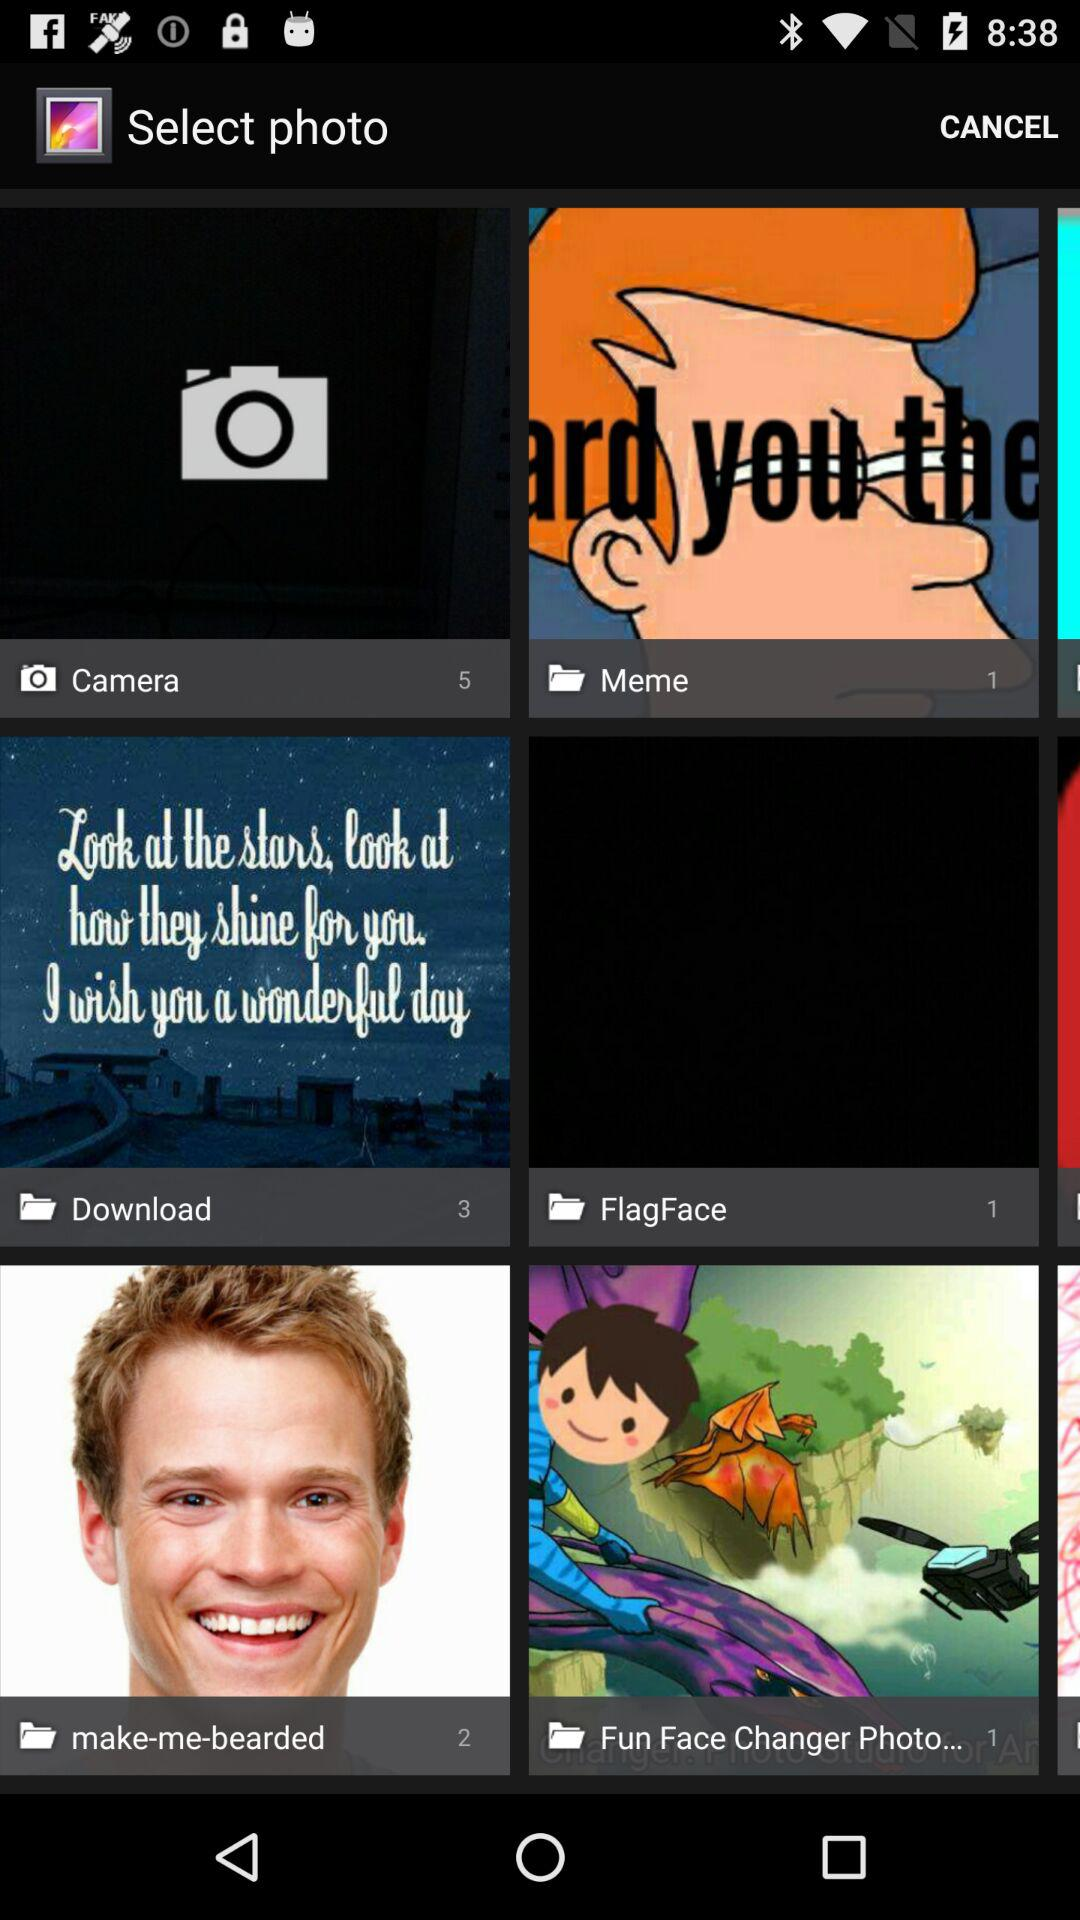How many photos are captured by the camera? The camera captured 5 photos. 